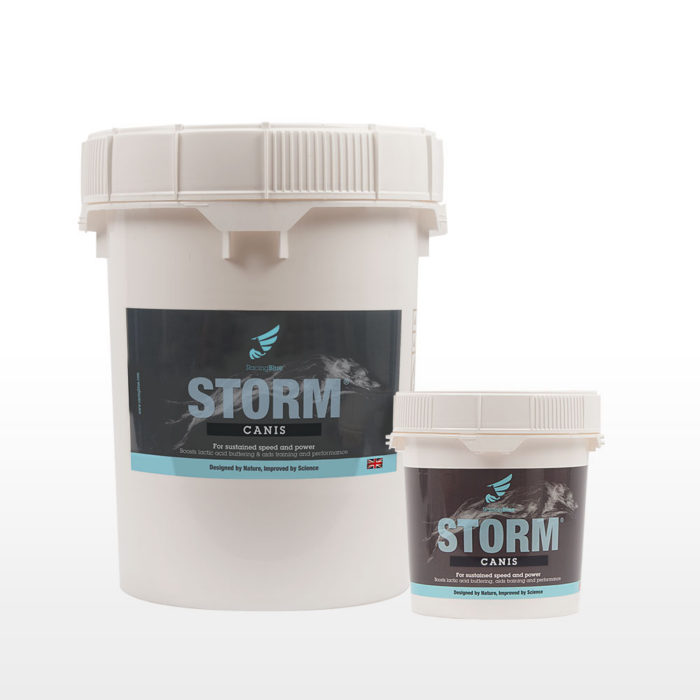Considering the branding and the labels on the containers, what might be the intended use or target consumer for the product "STORM CANIS"? The branding and labels of 'STORM CANIS' clearly suggest that it is a supplement formulated for dogs, aiming to enhance their physical performance, endurance, and overall health. The term 'CANIS' indicates its specific design for canine use. The product is likely packed with nutrients that support muscular strength, endurance, and speedy recovery, which can be particularly advantageous for working dogs, those involved in dog sports, or any highly active dogs. Moreover, the streamlined design and the phrase 'Designed by Nature, Improved by Science' hint at a blend of natural ingredients backed by scientific research to optimize canine fitness and performance. 